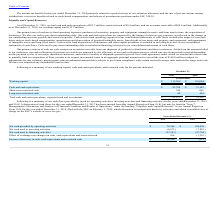According to Maxlinear's financial document, What is the Long-term restricted cash in 2019? According to the financial document, 60 (in thousands). The relevant text states: "Long-term restricted cash 60 404..." Also, can you calculate: What is the average Working capital for December 31, 2019 to 2018? To answer this question, I need to perform calculations using the financial data. The calculation is: (115,208+110,044) / 2, which equals 112626 (in thousands). This is based on the information: "Working capital $ 115,208 $ 110,044 Working capital $ 115,208 $ 110,044..." The key data points involved are: 110,044, 115,208. Also, can you calculate: What is the average Cash and cash equivalents for December 31, 2019 to 2018? To answer this question, I need to perform calculations using the financial data. The calculation is: (92,708+73,142) / 2, which equals 82925 (in thousands). This is based on the information: "Cash and cash equivalents $ 92,708 $ 73,142 Cash and cash equivalents $ 92,708 $ 73,142..." The key data points involved are: 73,142, 92,708. Additionally, In which year was Cash and cash equivalents less than 90,000 thousands? According to the financial document, 2018. The relevant text states: "2019 2018..." Also, What was the respective working capital in 2019 and 2018? The document shows two values: 115,208 and 110,044 (in thousands). From the document: "Working capital $ 115,208 $ 110,044 Working capital $ 115,208 $ 110,044..." Also, What was the cash and cash equivalents in 2019? According to the financial document, $92.7 million. The relevant text states: "mber 31, 2019, we had cash and cash equivalents of $92.7 million, restricted cash of $0.4 million, and net accounts receivable of $50.4 million. Additionally,..." 